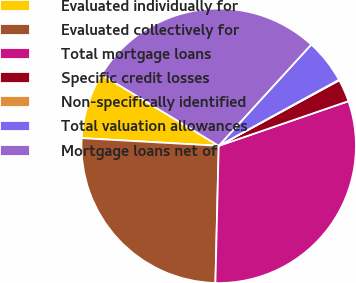Convert chart to OTSL. <chart><loc_0><loc_0><loc_500><loc_500><pie_chart><fcel>Evaluated individually for<fcel>Evaluated collectively for<fcel>Total mortgage loans<fcel>Specific credit losses<fcel>Non-specifically identified<fcel>Total valuation allowances<fcel>Mortgage loans net of<nl><fcel>7.8%<fcel>25.51%<fcel>30.66%<fcel>2.65%<fcel>0.07%<fcel>5.22%<fcel>28.09%<nl></chart> 